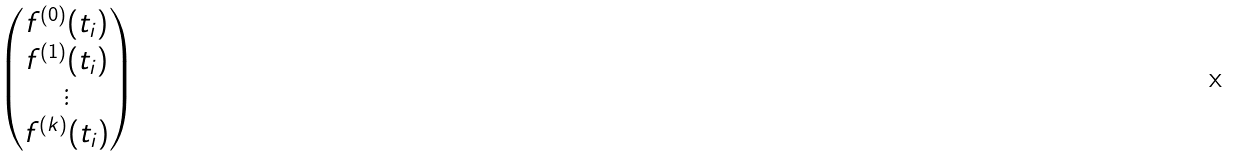<formula> <loc_0><loc_0><loc_500><loc_500>\begin{pmatrix} f ^ { ( 0 ) } ( t _ { i } ) \\ f ^ { ( 1 ) } ( t _ { i } ) \\ \vdots \\ f ^ { ( k ) } ( t _ { i } ) \end{pmatrix}</formula> 